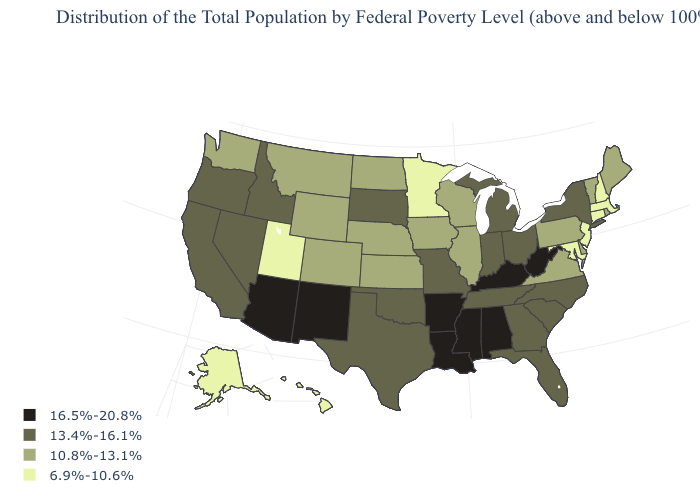Which states hav the highest value in the MidWest?
Short answer required. Indiana, Michigan, Missouri, Ohio, South Dakota. Name the states that have a value in the range 10.8%-13.1%?
Be succinct. Colorado, Delaware, Illinois, Iowa, Kansas, Maine, Montana, Nebraska, North Dakota, Pennsylvania, Rhode Island, Vermont, Virginia, Washington, Wisconsin, Wyoming. Which states have the lowest value in the South?
Answer briefly. Maryland. Does the map have missing data?
Concise answer only. No. What is the lowest value in the Northeast?
Keep it brief. 6.9%-10.6%. How many symbols are there in the legend?
Answer briefly. 4. What is the lowest value in states that border South Dakota?
Be succinct. 6.9%-10.6%. What is the value of Pennsylvania?
Answer briefly. 10.8%-13.1%. How many symbols are there in the legend?
Concise answer only. 4. Among the states that border Wyoming , which have the lowest value?
Concise answer only. Utah. Name the states that have a value in the range 6.9%-10.6%?
Write a very short answer. Alaska, Connecticut, Hawaii, Maryland, Massachusetts, Minnesota, New Hampshire, New Jersey, Utah. Among the states that border Michigan , which have the highest value?
Give a very brief answer. Indiana, Ohio. Name the states that have a value in the range 13.4%-16.1%?
Quick response, please. California, Florida, Georgia, Idaho, Indiana, Michigan, Missouri, Nevada, New York, North Carolina, Ohio, Oklahoma, Oregon, South Carolina, South Dakota, Tennessee, Texas. Among the states that border North Carolina , does Virginia have the lowest value?
Write a very short answer. Yes. 